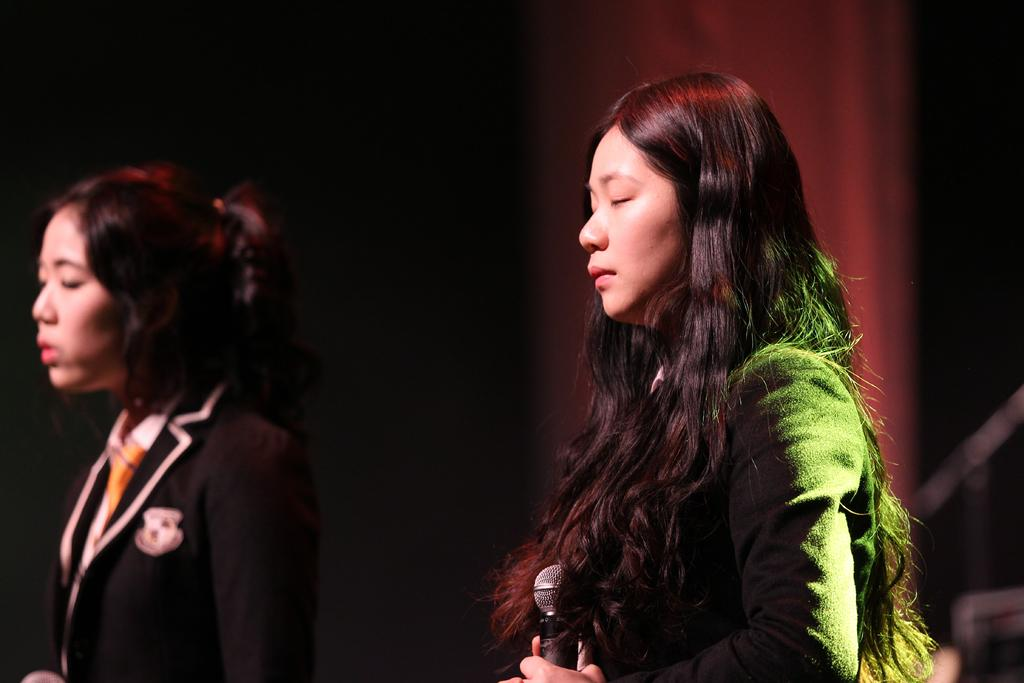How many women are in the image? There are two women in the image. What are the women doing in the image? Both women have their eyes closed and are facing towards the left side. What is the woman on the right side holding? The woman on the right side is holding a microphone in her hand. Can you describe the background of the image? The background of the image is blurred. What type of stamp can be seen on the woman's forehead in the image? There is no stamp visible on the women's foreheads in the image. What is the reaction of the women to the stamp in the image? There is no stamp or reaction to a stamp present in the image. 